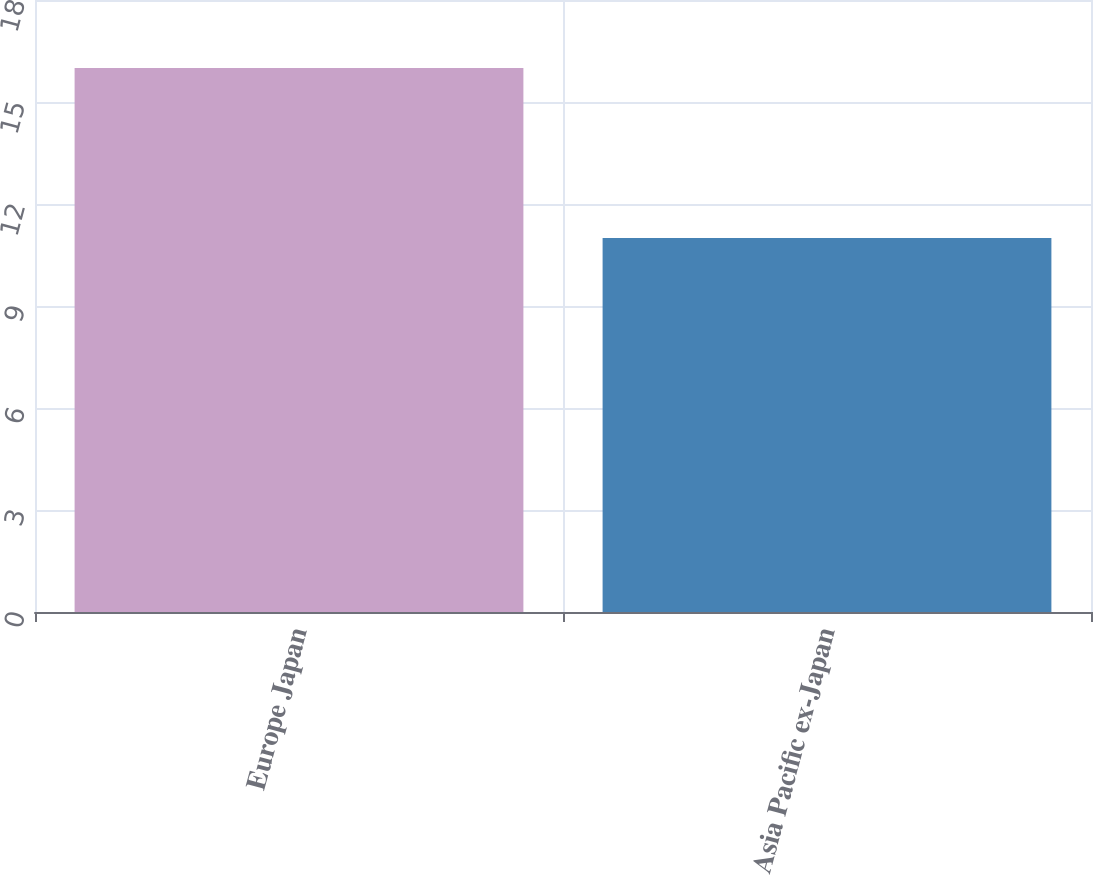<chart> <loc_0><loc_0><loc_500><loc_500><bar_chart><fcel>Europe Japan<fcel>Asia Pacific ex-Japan<nl><fcel>16<fcel>11<nl></chart> 